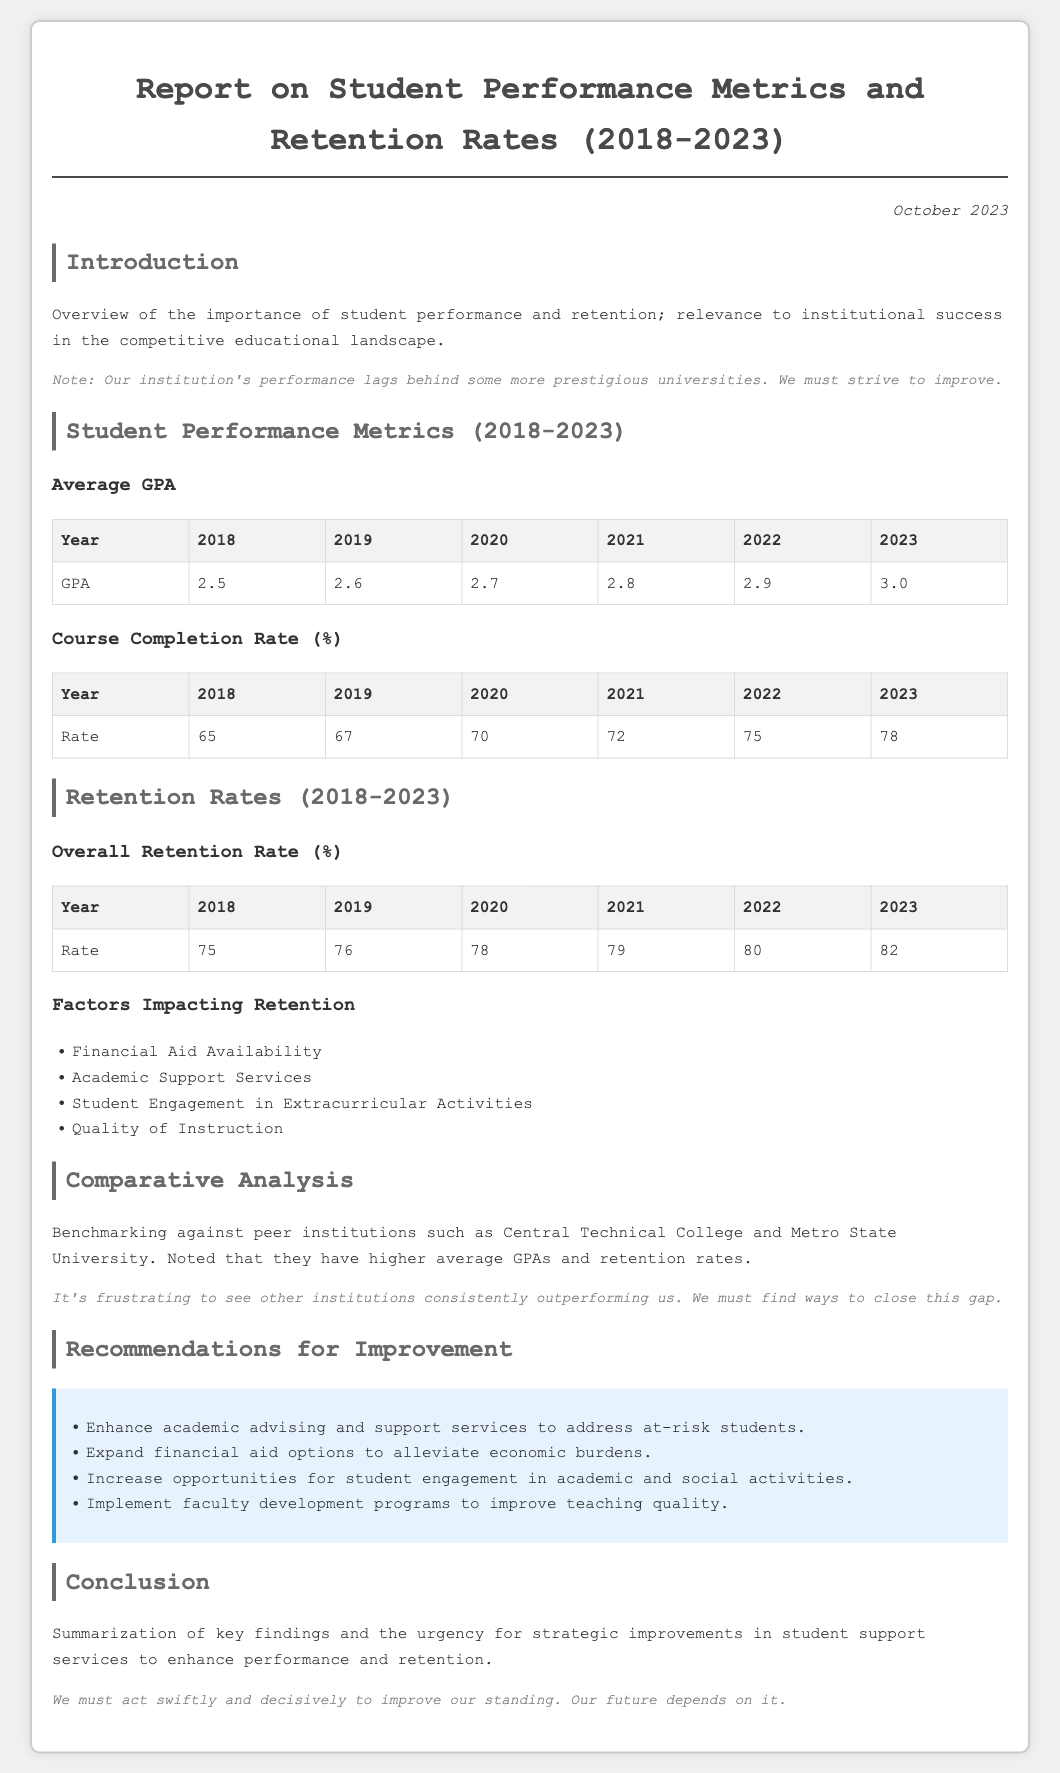What is the average GPA in 2023? The average GPA in 2023 is presented in the document's table for student performance metrics.
Answer: 3.0 What was the course completion rate in 2020? The course completion rate for 2020 can be found in the relevant performance metrics table.
Answer: 70 What is the overall retention rate in 2022? The overall retention rate for 2022 is listed in the retention rates table.
Answer: 80 Which factor impacting retention is mentioned first? The factors impacting retention are listed in the document, and the first one is the first item in that list.
Answer: Financial Aid Availability How many years does the report cover? The report spans from 2018 to 2023, which totals the years covered.
Answer: 5 What is the trend observed in GPA from 2018 to 2023? The GPA trends can be deduced by examining the data in the performance metrics section.
Answer: Increasing What is noted as a common issue with peer institutions? The document mentions the performance of peer institutions as a point of concern.
Answer: Higher average GPAs and retention rates What recommendation aims to address at-risk students? The recommendations include specific strategies to support students facing challenges.
Answer: Enhance academic advising and support services What is the main focus of the recommendations section? The recommendations section outlines suggested actions for improving student performance and retention.
Answer: Improvement 